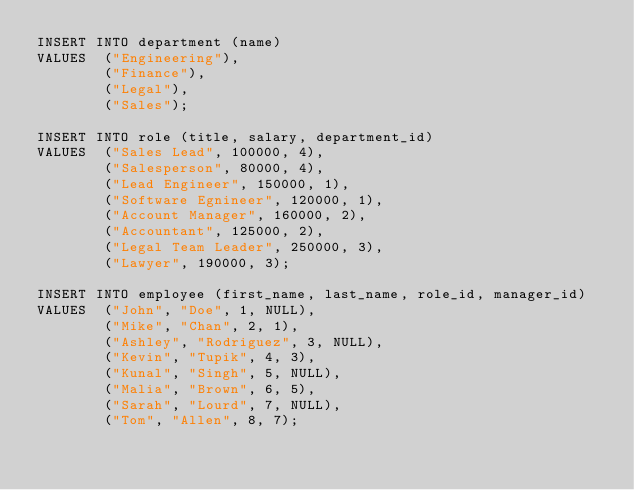Convert code to text. <code><loc_0><loc_0><loc_500><loc_500><_SQL_>INSERT INTO department (name)
VALUES  ("Engineering"),
        ("Finance"),
        ("Legal"),
        ("Sales");

INSERT INTO role (title, salary, department_id)
VALUES  ("Sales Lead", 100000, 4),
        ("Salesperson", 80000, 4),
        ("Lead Engineer", 150000, 1),
        ("Software Egnineer", 120000, 1),
        ("Account Manager", 160000, 2),
        ("Accountant", 125000, 2),
        ("Legal Team Leader", 250000, 3),
        ("Lawyer", 190000, 3);

INSERT INTO employee (first_name, last_name, role_id, manager_id)
VALUES  ("John", "Doe", 1, NULL),
        ("Mike", "Chan", 2, 1),
        ("Ashley", "Rodriguez", 3, NULL),
        ("Kevin", "Tupik", 4, 3),
        ("Kunal", "Singh", 5, NULL),
        ("Malia", "Brown", 6, 5),
        ("Sarah", "Lourd", 7, NULL),
        ("Tom", "Allen", 8, 7);</code> 